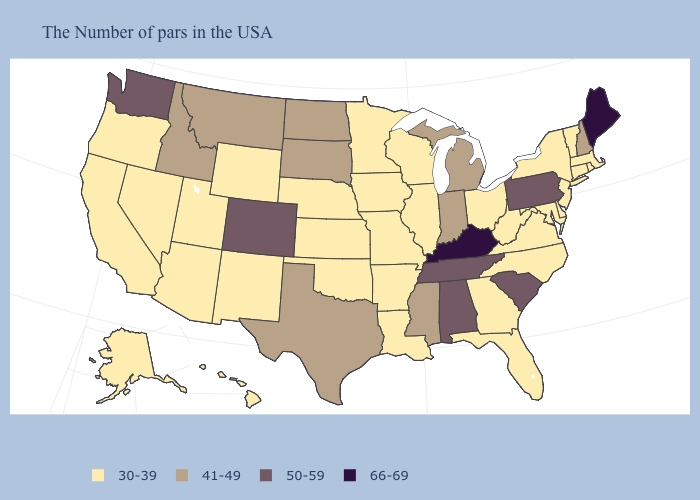Among the states that border New Hampshire , which have the highest value?
Give a very brief answer. Maine. Does Wisconsin have the highest value in the MidWest?
Short answer required. No. Does the first symbol in the legend represent the smallest category?
Short answer required. Yes. Is the legend a continuous bar?
Concise answer only. No. What is the value of Connecticut?
Give a very brief answer. 30-39. Among the states that border Kentucky , does Illinois have the highest value?
Short answer required. No. Among the states that border Oregon , which have the lowest value?
Answer briefly. Nevada, California. How many symbols are there in the legend?
Be succinct. 4. What is the value of Oklahoma?
Answer briefly. 30-39. Does the map have missing data?
Be succinct. No. Which states have the lowest value in the MidWest?
Answer briefly. Ohio, Wisconsin, Illinois, Missouri, Minnesota, Iowa, Kansas, Nebraska. What is the lowest value in states that border Virginia?
Give a very brief answer. 30-39. Does the map have missing data?
Answer briefly. No. Does the map have missing data?
Short answer required. No. Does Maine have the highest value in the Northeast?
Concise answer only. Yes. 